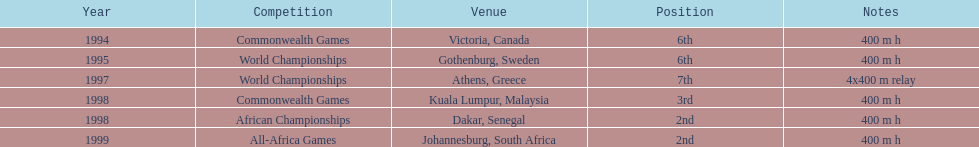In what years did ken harnden do better that 5th place? 1998, 1999. 